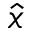<formula> <loc_0><loc_0><loc_500><loc_500>\hat { x }</formula> 